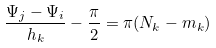Convert formula to latex. <formula><loc_0><loc_0><loc_500><loc_500>\frac { \Psi _ { j } - \Psi _ { i } } { h _ { k } } - \frac { \pi } { 2 } = \pi ( N _ { k } - m _ { k } )</formula> 